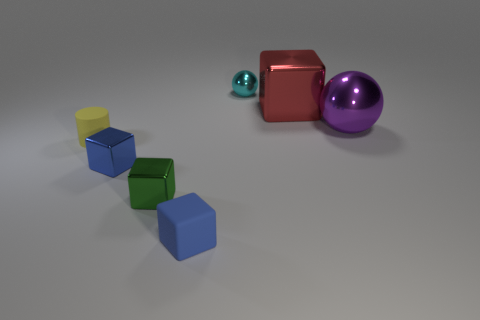Subtract all blue blocks. How many were subtracted if there are1blue blocks left? 1 Add 2 small shiny cubes. How many objects exist? 9 Subtract all blocks. How many objects are left? 3 Add 5 gray things. How many gray things exist? 5 Subtract 1 yellow cylinders. How many objects are left? 6 Subtract all cyan rubber cylinders. Subtract all small blue blocks. How many objects are left? 5 Add 2 big metal spheres. How many big metal spheres are left? 3 